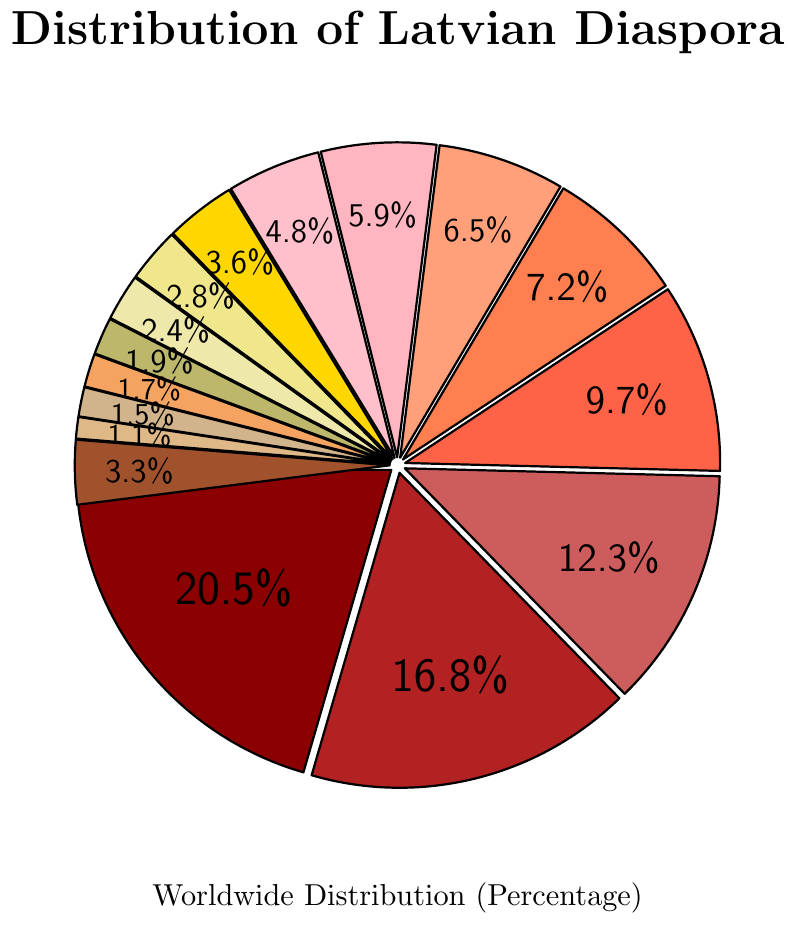Which country has the highest percentage of the Latvian diaspora? The United States has the highest percentage as represented by the largest segment of the pie chart, with 20.5%.
Answer: The United States Which country has the smallest percentage of the Latvian diaspora? New Zealand has the smallest percentage as represented by the smallest segment of the pie chart, with 1.1%.
Answer: New Zealand How do the percentages of the Latvian diaspora in the United States and Canada compare? The United States has a higher percentage of the Latvian diaspora compared to Canada. The United States has 20.5% while Canada has 7.2%.
Answer: The United States has a higher percentage What is the combined percentage of the Latvian diaspora in the United Kingdom and Ireland? Add the percentages for the United Kingdom (16.8%) and Ireland (12.3%). The combined percentage is 16.8% + 12.3% = 29.1%.
Answer: 29.1% How much more significant is the Latvian diaspora in Germany compared to Russia? Subtract the percentage of Russia (3.6%) from the percentage of Germany (9.7%). The difference is 9.7% - 3.6% = 6.1%.
Answer: 6.1% Which three countries in Europe have the highest percentage of the Latvian diaspora? The highest percentages in Europe after the United Kingdom and Ireland are Germany (9.7%), Norway (6.5%), and Sweden (5.9%).
Answer: Germany, Norway, and Sweden What is the average percentage of the Latvian diaspora in Australia, New Zealand, and Canada? Add the percentages for Australia (4.8%), New Zealand (1.1%), and Canada (7.2%), then divide by 3. The average is (4.8% + 1.1% + 7.2%) / 3 = 4.37%.
Answer: 4.37% Between Norway and Sweden, which country has a larger segment in the pie chart? Norway has a larger segment compared to Sweden. Norway has 6.5% while Sweden has 5.9%.
Answer: Norway What is the combined percentage of the Latvian diaspora in the Scandinavian countries (Norway, Sweden, Denmark, and Finland)? Add the percentages for Norway (6.5%), Sweden (5.9%), Denmark (2.8%), and Finland (1.7%). The combined percentage is 6.5% + 5.9% + 2.8% + 1.7% = 16.9%.
Answer: 16.9% What percentage of the Latvian diaspora is in countries outside of the top 15 listed? The percentage for 'Other countries' is directly listed as 3.3% in the pie chart.
Answer: 3.3% 